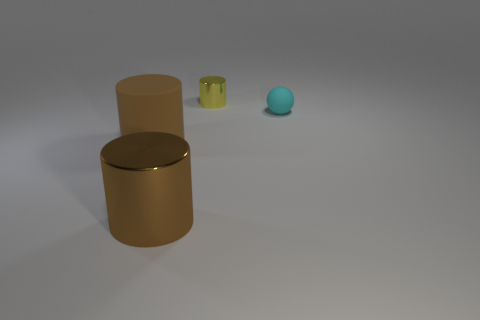Do the shiny object that is in front of the yellow metal cylinder and the rubber cylinder have the same color?
Provide a short and direct response. Yes. There is a metal thing on the right side of the metal object in front of the tiny cyan rubber object; how many cylinders are in front of it?
Offer a very short reply. 2. The small metallic cylinder that is left of the tiny rubber object is what color?
Offer a terse response. Yellow. What is the shape of the large brown thing left of the metal cylinder that is in front of the tiny cyan matte ball?
Ensure brevity in your answer.  Cylinder. Is the color of the small sphere the same as the tiny metal cylinder?
Offer a very short reply. No. How many blocks are either brown matte things or cyan objects?
Provide a succinct answer. 0. The thing that is both on the left side of the tiny cyan matte object and behind the brown rubber thing is made of what material?
Offer a very short reply. Metal. How many big shiny cylinders are on the right side of the small yellow metal thing?
Provide a short and direct response. 0. Are the small thing that is in front of the tiny metallic cylinder and the brown object that is in front of the rubber cylinder made of the same material?
Provide a short and direct response. No. How many objects are metallic objects in front of the small cylinder or large brown spheres?
Your answer should be very brief. 1. 